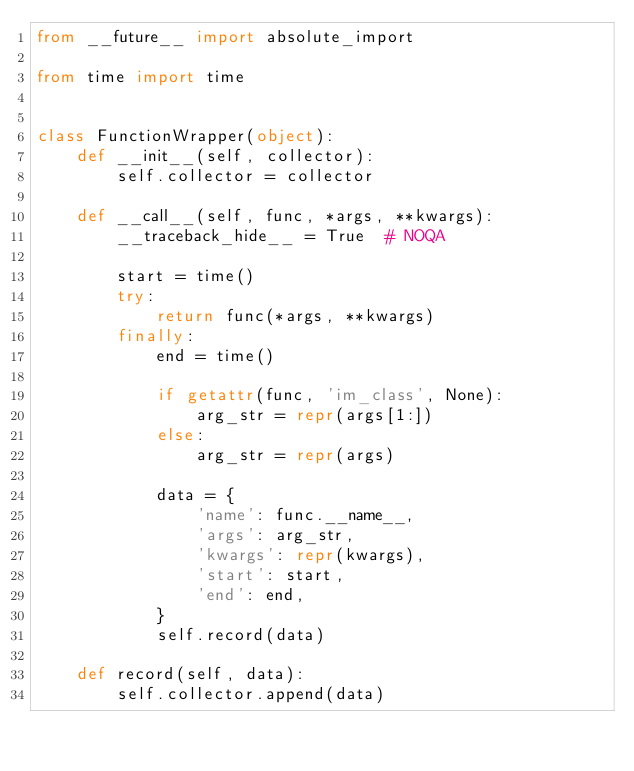<code> <loc_0><loc_0><loc_500><loc_500><_Python_>from __future__ import absolute_import

from time import time


class FunctionWrapper(object):
    def __init__(self, collector):
        self.collector = collector

    def __call__(self, func, *args, **kwargs):
        __traceback_hide__ = True  # NOQA

        start = time()
        try:
            return func(*args, **kwargs)
        finally:
            end = time()

            if getattr(func, 'im_class', None):
                arg_str = repr(args[1:])
            else:
                arg_str = repr(args)

            data = {
                'name': func.__name__,
                'args': arg_str,
                'kwargs': repr(kwargs),
                'start': start,
                'end': end,
            }
            self.record(data)

    def record(self, data):
        self.collector.append(data)
</code> 